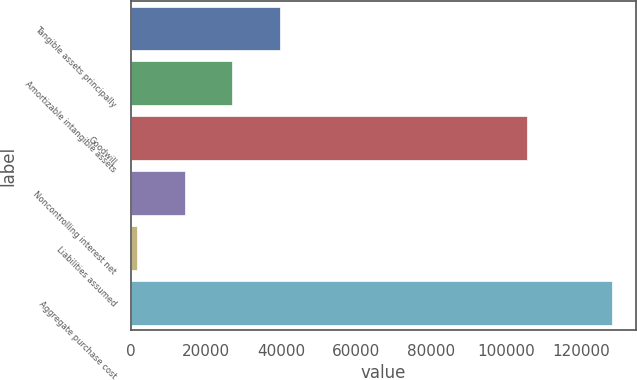<chart> <loc_0><loc_0><loc_500><loc_500><bar_chart><fcel>Tangible assets principally<fcel>Amortizable intangible assets<fcel>Goodwill<fcel>Noncontrolling interest net<fcel>Liabilities assumed<fcel>Aggregate purchase cost<nl><fcel>39669<fcel>27009<fcel>105609<fcel>14349<fcel>1689<fcel>128289<nl></chart> 